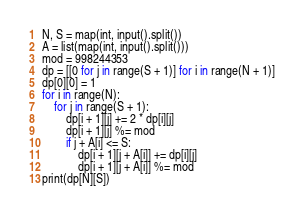<code> <loc_0><loc_0><loc_500><loc_500><_Python_>N, S = map(int, input().split())
A = list(map(int, input().split()))
mod = 998244353
dp = [[0 for j in range(S + 1)] for i in range(N + 1)]
dp[0][0] = 1
for i in range(N):
    for j in range(S + 1):
        dp[i + 1][j] += 2 * dp[i][j]
        dp[i + 1][j] %= mod
        if j + A[i] <= S:
            dp[i + 1][j + A[i]] += dp[i][j]
            dp[i + 1][j + A[i]] %= mod
print(dp[N][S])
</code> 